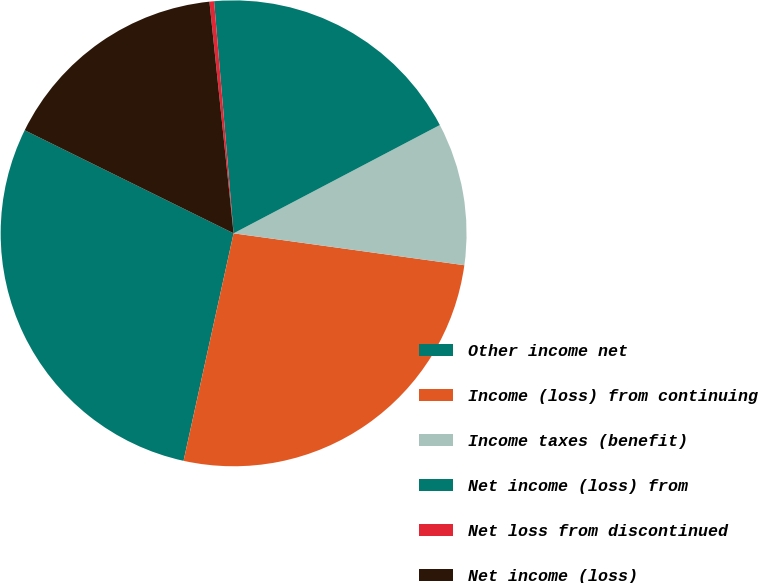<chart> <loc_0><loc_0><loc_500><loc_500><pie_chart><fcel>Other income net<fcel>Income (loss) from continuing<fcel>Income taxes (benefit)<fcel>Net income (loss) from<fcel>Net loss from discontinued<fcel>Net income (loss)<nl><fcel>28.85%<fcel>26.26%<fcel>9.88%<fcel>18.64%<fcel>0.32%<fcel>16.05%<nl></chart> 